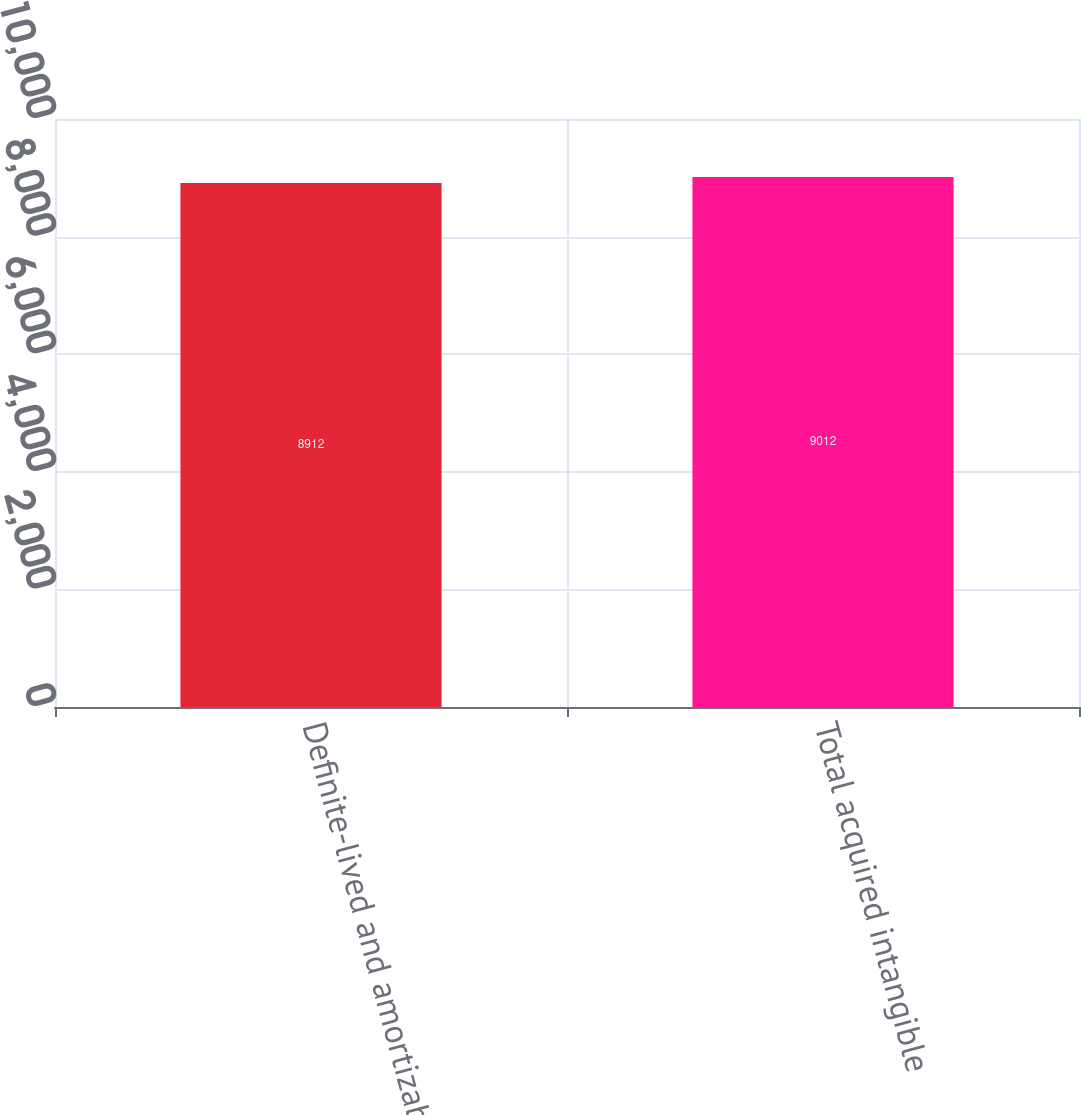<chart> <loc_0><loc_0><loc_500><loc_500><bar_chart><fcel>Definite-lived and amortizable<fcel>Total acquired intangible<nl><fcel>8912<fcel>9012<nl></chart> 